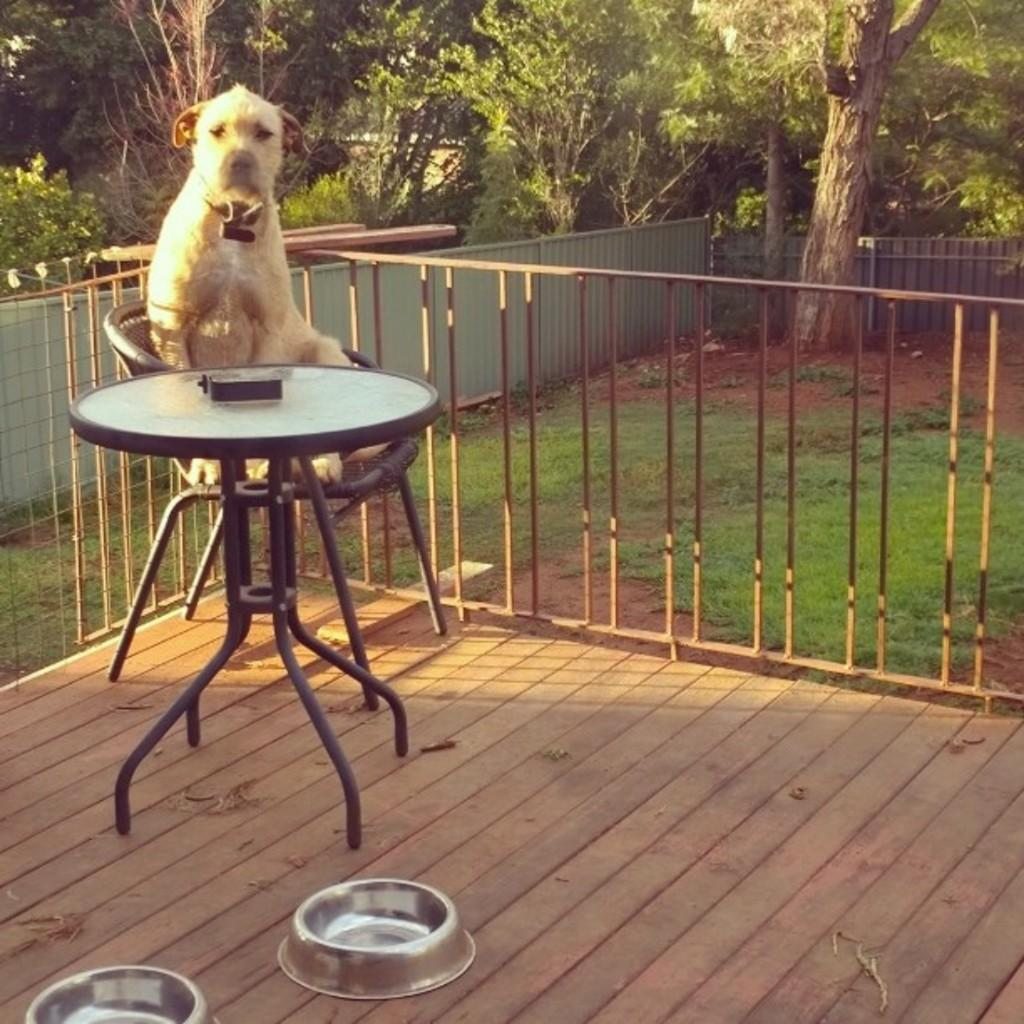What type of animal is in the image? There is a dog in the image. Where is the dog sitting? The dog is sitting on a chair. What is in front of the dog? There is a table in front of the dog. What can be seen on the floor near the dog? There are two bowls on the floor. What is visible in the background of the image? There is a railing and a tree in the background. What game is the dog playing with the voice in the image? There is no game or voice present in the image; it features a dog sitting on a chair with a table in front of it and two bowls on the floor. 